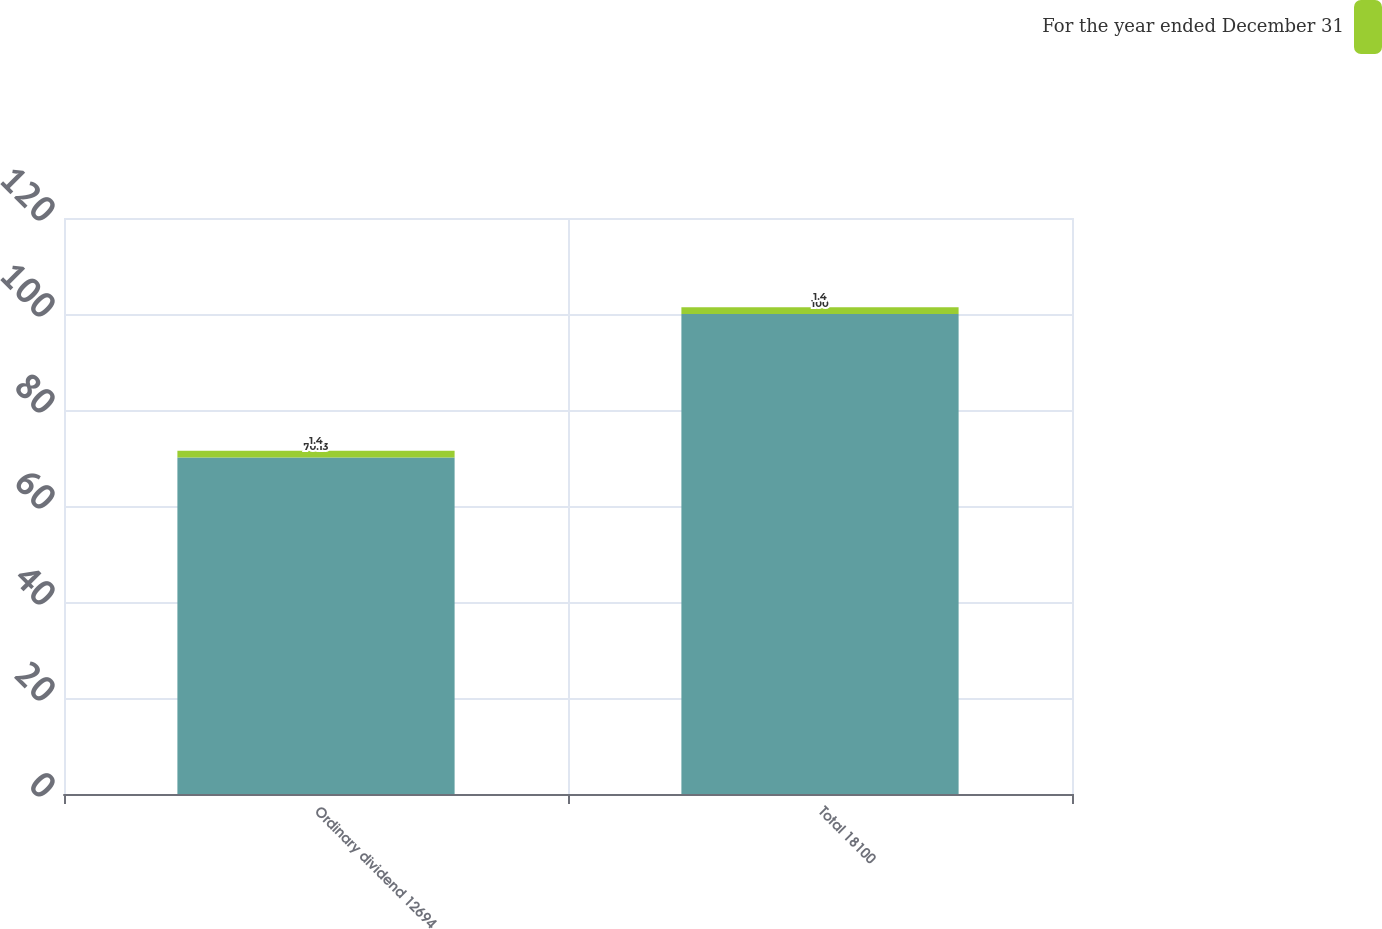<chart> <loc_0><loc_0><loc_500><loc_500><stacked_bar_chart><ecel><fcel>Ordinary dividend 12694<fcel>Total 18100<nl><fcel>nan<fcel>70.13<fcel>100<nl><fcel>For the year ended December 31<fcel>1.4<fcel>1.4<nl></chart> 